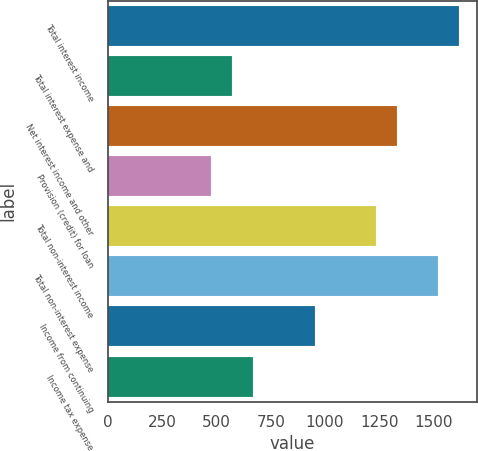<chart> <loc_0><loc_0><loc_500><loc_500><bar_chart><fcel>Total interest income<fcel>Total interest expense and<fcel>Net interest income and other<fcel>Provision (credit) for loan<fcel>Total non-interest income<fcel>Total non-interest expense<fcel>Income from continuing<fcel>Income tax expense<nl><fcel>1618.3<fcel>571.21<fcel>1332.73<fcel>476.02<fcel>1237.54<fcel>1523.11<fcel>951.97<fcel>666.4<nl></chart> 